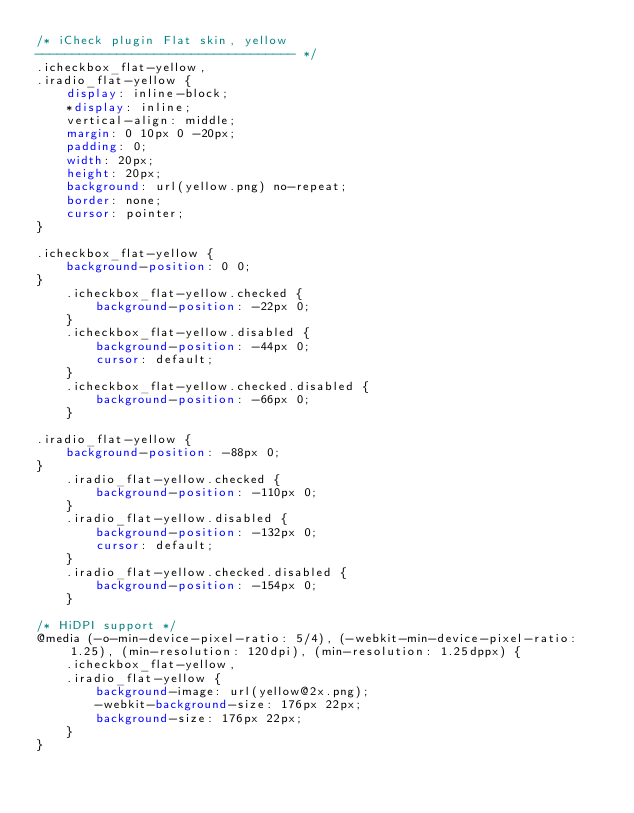Convert code to text. <code><loc_0><loc_0><loc_500><loc_500><_CSS_>/* iCheck plugin Flat skin, yellow
----------------------------------- */
.icheckbox_flat-yellow,
.iradio_flat-yellow {
    display: inline-block;
    *display: inline;
    vertical-align: middle;
    margin: 0 10px 0 -20px;
    padding: 0;
    width: 20px;
    height: 20px;
    background: url(yellow.png) no-repeat;
    border: none;
    cursor: pointer;
}

.icheckbox_flat-yellow {
    background-position: 0 0;
}
    .icheckbox_flat-yellow.checked {
        background-position: -22px 0;
    }
    .icheckbox_flat-yellow.disabled {
        background-position: -44px 0;
        cursor: default;
    }
    .icheckbox_flat-yellow.checked.disabled {
        background-position: -66px 0;
    }

.iradio_flat-yellow {
    background-position: -88px 0;
}
    .iradio_flat-yellow.checked {
        background-position: -110px 0;
    }
    .iradio_flat-yellow.disabled {
        background-position: -132px 0;
        cursor: default;
    }
    .iradio_flat-yellow.checked.disabled {
        background-position: -154px 0;
    }

/* HiDPI support */
@media (-o-min-device-pixel-ratio: 5/4), (-webkit-min-device-pixel-ratio: 1.25), (min-resolution: 120dpi), (min-resolution: 1.25dppx) {
    .icheckbox_flat-yellow,
    .iradio_flat-yellow {
        background-image: url(yellow@2x.png);
        -webkit-background-size: 176px 22px;
        background-size: 176px 22px;
    }
}</code> 